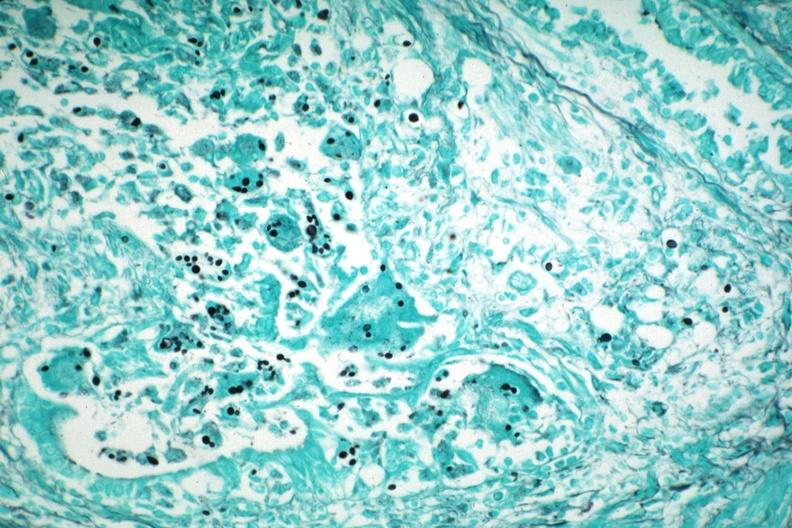what illustrates organisms granulomatous prostatitis aids case?
Answer the question using a single word or phrase. Gms 